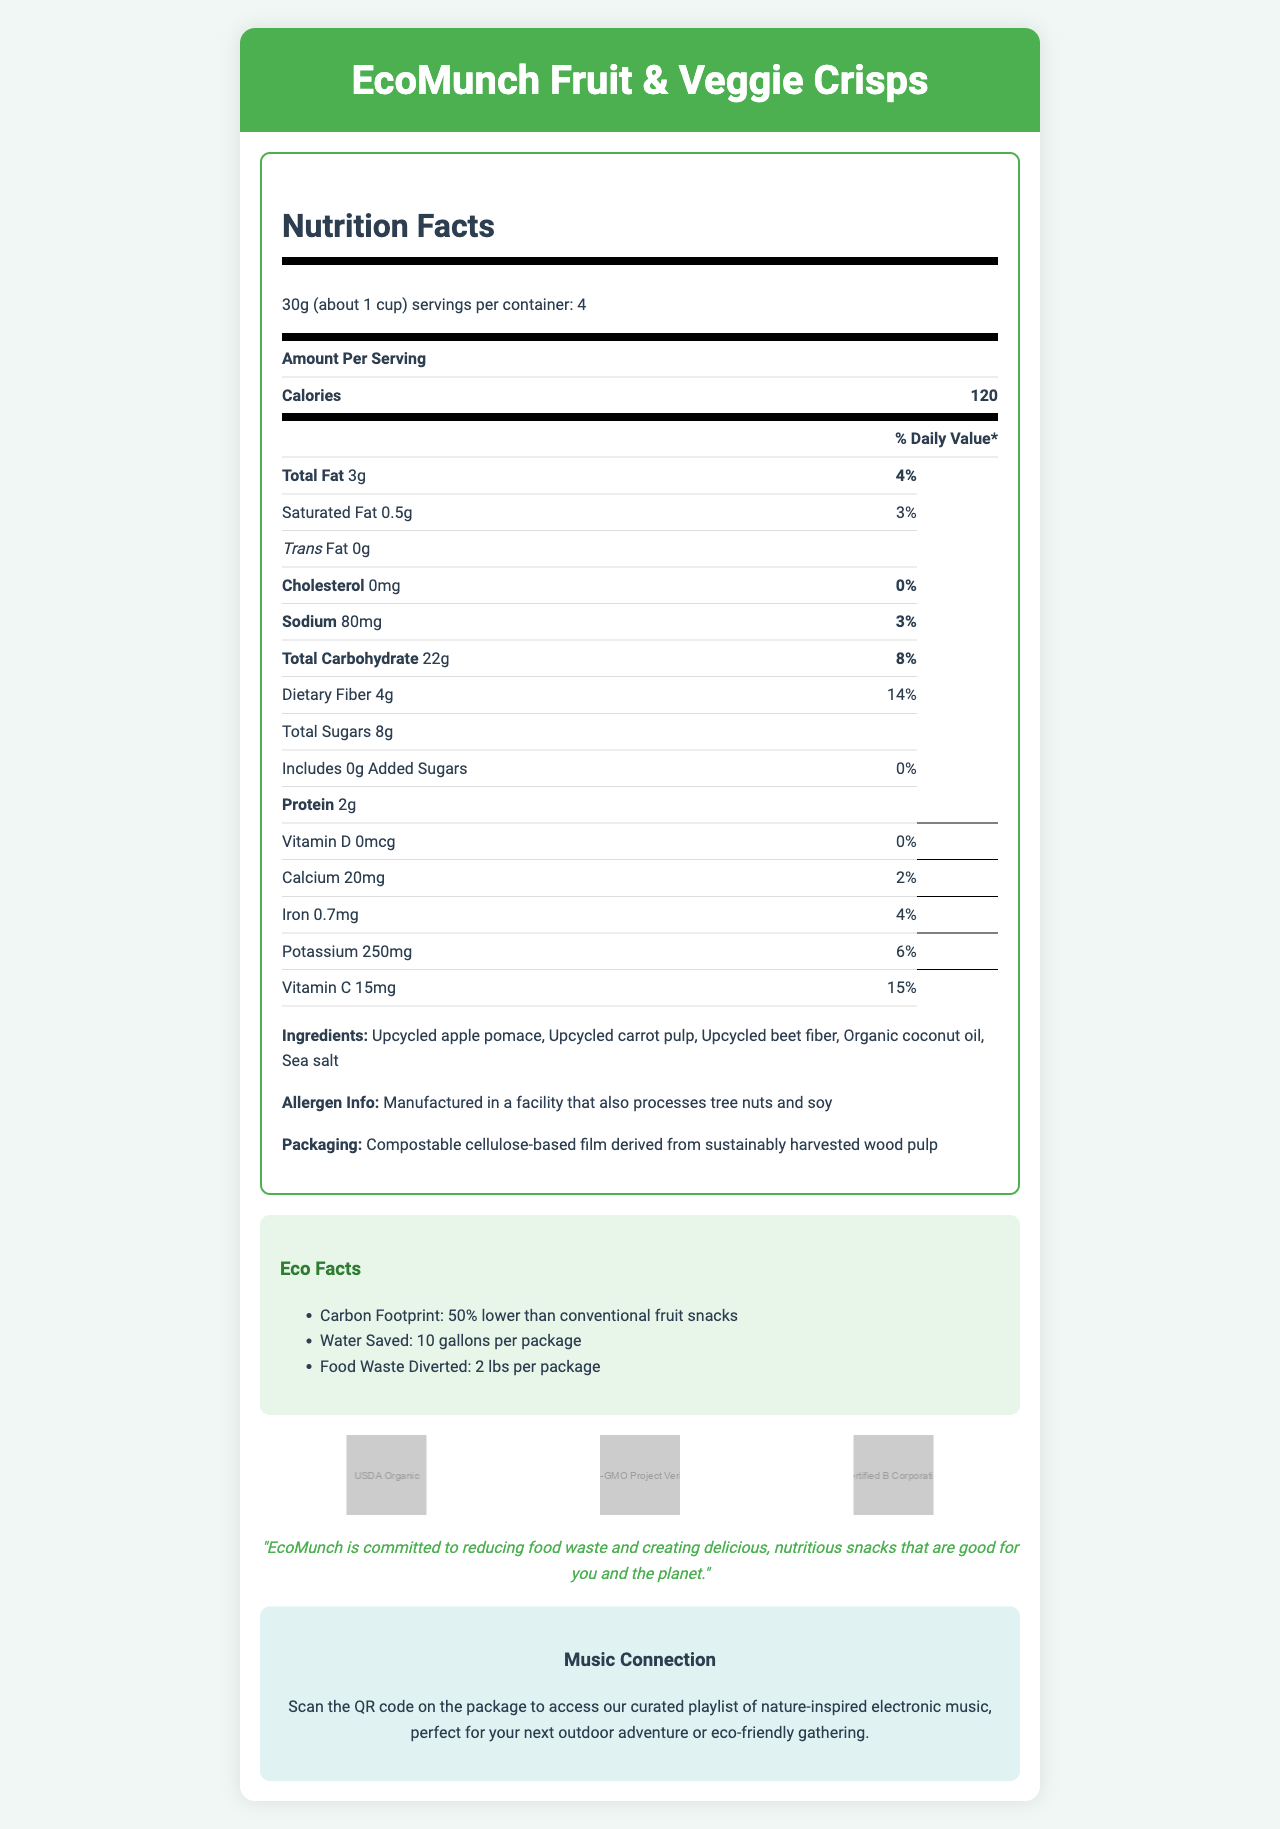what is the serving size for EcoMunch Fruit & Veggie Crisps? The serving size is listed directly under the product name as "30g (about 1 cup)".
Answer: 30g (about 1 cup) how many servings are there per container? The number of servings per container is stated as "4".
Answer: 4 how many grams of dietary fiber are in one serving? The dietary fiber content per serving is listed as "4g".
Answer: 4g what is the percentage daily value of calcium in one serving? The percentage daily value of calcium is provided as "2%".
Answer: 2% list three ingredients found in EcoMunch Fruit & Veggie Crisps The ingredients listed include "Upcycled apple pomace, Upcycled carrot pulp, Upcycled beet fiber, Organic coconut oil, Sea salt".
Answer: Upcycled apple pomace, Upcycled carrot pulp, Upcycled beet fiber which of the following nutrients are included in the crisps? A. Vitamin A B. Vitamin D C. Vitamin C D. Vitamin B12 Vitamin C is listed with its amount and daily value, while the other options are not mentioned in the document.
Answer: C what is the total amount of sugars in one serving? A. 6g B. 8g C. 10g D. 12g The total amount of sugars in one serving is stated as "8g".
Answer: B what percentage of the daily value of iron is in one serving? The document lists the daily value of iron as "4%".
Answer: 4% is there any added sugar in the crisps? The amount of added sugars is "0g" and the daily value is also "0%".
Answer: No describe the sustainability aspects of the EcoMunch Fruit & Veggie Crisps. The document highlights that the crisps are made from upcycled apple pomace, carrot pulp, and beet fiber, are packaged in compostable cellulose-based film, and have a 50% lower carbon footprint, save 10 gallons of water per package, and divert 2 lbs of food waste per package.
Answer: The product is made from upcycled fruit and vegetable waste, packaged in compostable film, and has lower carbon footprint and water usage. how much protein is in one serving of EcoMunch Fruit & Veggie Crisps? The protein content per serving is indicated as "2g".
Answer: 2g what is the main idea of the EcoMunch Fruit & Veggie Crisps document? The main idea is to describe EcoMunch Fruit & Veggie Crisps, including detailed nutrition facts, its eco-friendly features, certifications, delicious ingredients, and the added value of a nature-inspired musical experience.
Answer: The document provides nutritional information, lists ingredients, highlights eco-friendly aspects and certifications, and connects the product to nature-inspired music. what are the certifications associated with EcoMunch Fruit & Veggie Crisps? The document lists these three certifications under the "certifications" section.
Answer: USDA Organic, Non-GMO Project Verified, Certified B Corporation how much potassium is in one serving? The potassium content per serving is stated as "250mg".
Answer: 250mg what is the purpose of the QR code on the package? The document mentions that scanning the QR code gives access to a playlist related to nature-inspired electronic music.
Answer: To access a curated playlist of nature-inspired electronic music where are these fruit and vegetable crisps manufactured? The document does not provide information on the manufacturing location.
Answer: Not enough information 